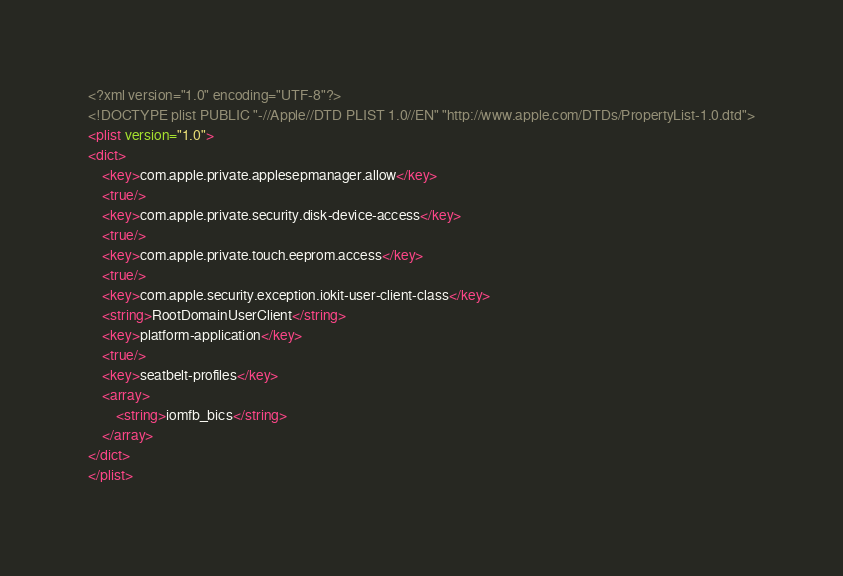<code> <loc_0><loc_0><loc_500><loc_500><_XML_><?xml version="1.0" encoding="UTF-8"?>
<!DOCTYPE plist PUBLIC "-//Apple//DTD PLIST 1.0//EN" "http://www.apple.com/DTDs/PropertyList-1.0.dtd">
<plist version="1.0">
<dict>
	<key>com.apple.private.applesepmanager.allow</key>
	<true/>
	<key>com.apple.private.security.disk-device-access</key>
	<true/>
	<key>com.apple.private.touch.eeprom.access</key>
	<true/>
	<key>com.apple.security.exception.iokit-user-client-class</key>
	<string>RootDomainUserClient</string>
	<key>platform-application</key>
	<true/>
	<key>seatbelt-profiles</key>
	<array>
		<string>iomfb_bics</string>
	</array>
</dict>
</plist>
</code> 